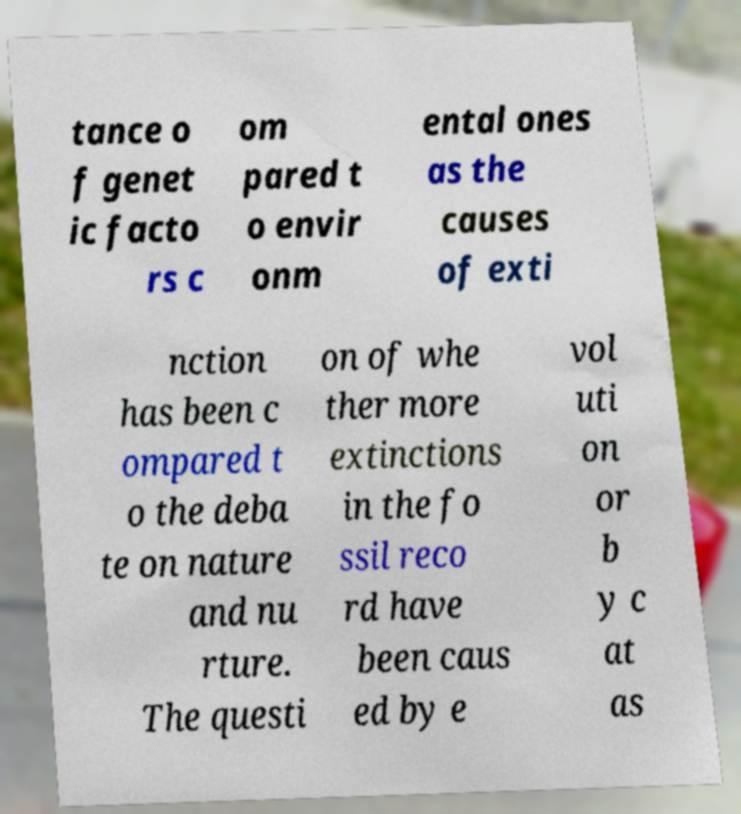For documentation purposes, I need the text within this image transcribed. Could you provide that? tance o f genet ic facto rs c om pared t o envir onm ental ones as the causes of exti nction has been c ompared t o the deba te on nature and nu rture. The questi on of whe ther more extinctions in the fo ssil reco rd have been caus ed by e vol uti on or b y c at as 